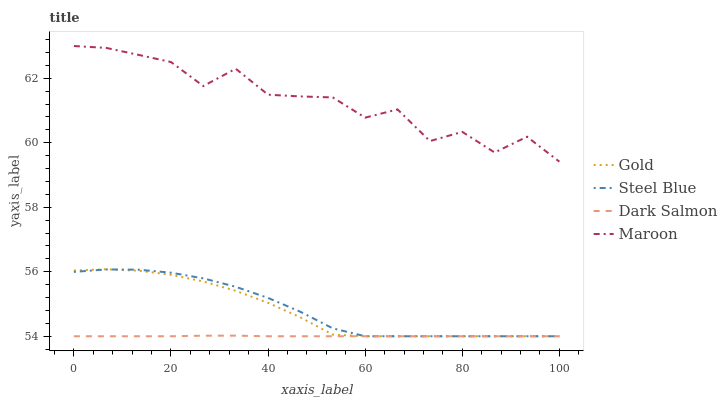Does Dark Salmon have the minimum area under the curve?
Answer yes or no. Yes. Does Maroon have the maximum area under the curve?
Answer yes or no. Yes. Does Steel Blue have the minimum area under the curve?
Answer yes or no. No. Does Steel Blue have the maximum area under the curve?
Answer yes or no. No. Is Dark Salmon the smoothest?
Answer yes or no. Yes. Is Maroon the roughest?
Answer yes or no. Yes. Is Steel Blue the smoothest?
Answer yes or no. No. Is Steel Blue the roughest?
Answer yes or no. No. Does Steel Blue have the lowest value?
Answer yes or no. Yes. Does Maroon have the highest value?
Answer yes or no. Yes. Does Steel Blue have the highest value?
Answer yes or no. No. Is Dark Salmon less than Maroon?
Answer yes or no. Yes. Is Maroon greater than Steel Blue?
Answer yes or no. Yes. Does Dark Salmon intersect Steel Blue?
Answer yes or no. Yes. Is Dark Salmon less than Steel Blue?
Answer yes or no. No. Is Dark Salmon greater than Steel Blue?
Answer yes or no. No. Does Dark Salmon intersect Maroon?
Answer yes or no. No. 